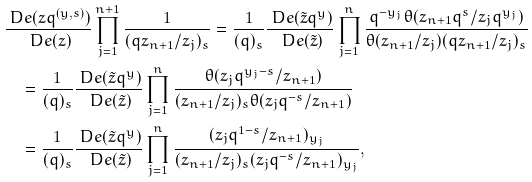Convert formula to latex. <formula><loc_0><loc_0><loc_500><loc_500>& \frac { \ D e ( z q ^ { ( y , s ) } ) } { \ D e ( z ) } \prod _ { j = 1 } ^ { n + 1 } \frac { 1 } { ( q z _ { n + 1 } / z _ { j } ) _ { s } } = \frac { 1 } { ( q ) _ { s } } \frac { \ D e ( \tilde { z } q ^ { y } ) } { \ D e ( \tilde { z } ) } \prod _ { j = 1 } ^ { n } \frac { q ^ { - y _ { j } } \theta ( z _ { n + 1 } q ^ { s } / z _ { j } q ^ { y _ { j } } ) } { \theta ( z _ { n + 1 } / z _ { j } ) ( q z _ { n + 1 } / z _ { j } ) _ { s } } \\ & \quad = \frac { 1 } { ( q ) _ { s } } \frac { \ D e ( \tilde { z } q ^ { y } ) } { \ D e ( \tilde { z } ) } \prod _ { j = 1 } ^ { n } \frac { \theta ( z _ { j } q ^ { y _ { j } - s } / z _ { n + 1 } ) } { ( z _ { n + 1 } / z _ { j } ) _ { s } \theta ( z _ { j } q ^ { - s } / z _ { n + 1 } ) } \\ & \quad = \frac { 1 } { ( q ) _ { s } } \frac { \ D e ( \tilde { z } q ^ { y } ) } { \ D e ( \tilde { z } ) } \prod _ { j = 1 } ^ { n } \frac { ( z _ { j } q ^ { 1 - s } / z _ { n + 1 } ) _ { y _ { j } } } { ( z _ { n + 1 } / z _ { j } ) _ { s } ( z _ { j } q ^ { - s } / z _ { n + 1 } ) _ { y _ { j } } } ,</formula> 